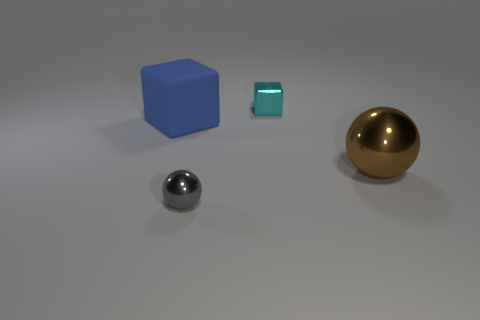Add 3 cubes. How many objects exist? 7 Subtract all metal spheres. Subtract all big brown balls. How many objects are left? 1 Add 3 large blocks. How many large blocks are left? 4 Add 3 blue objects. How many blue objects exist? 4 Subtract 0 purple spheres. How many objects are left? 4 